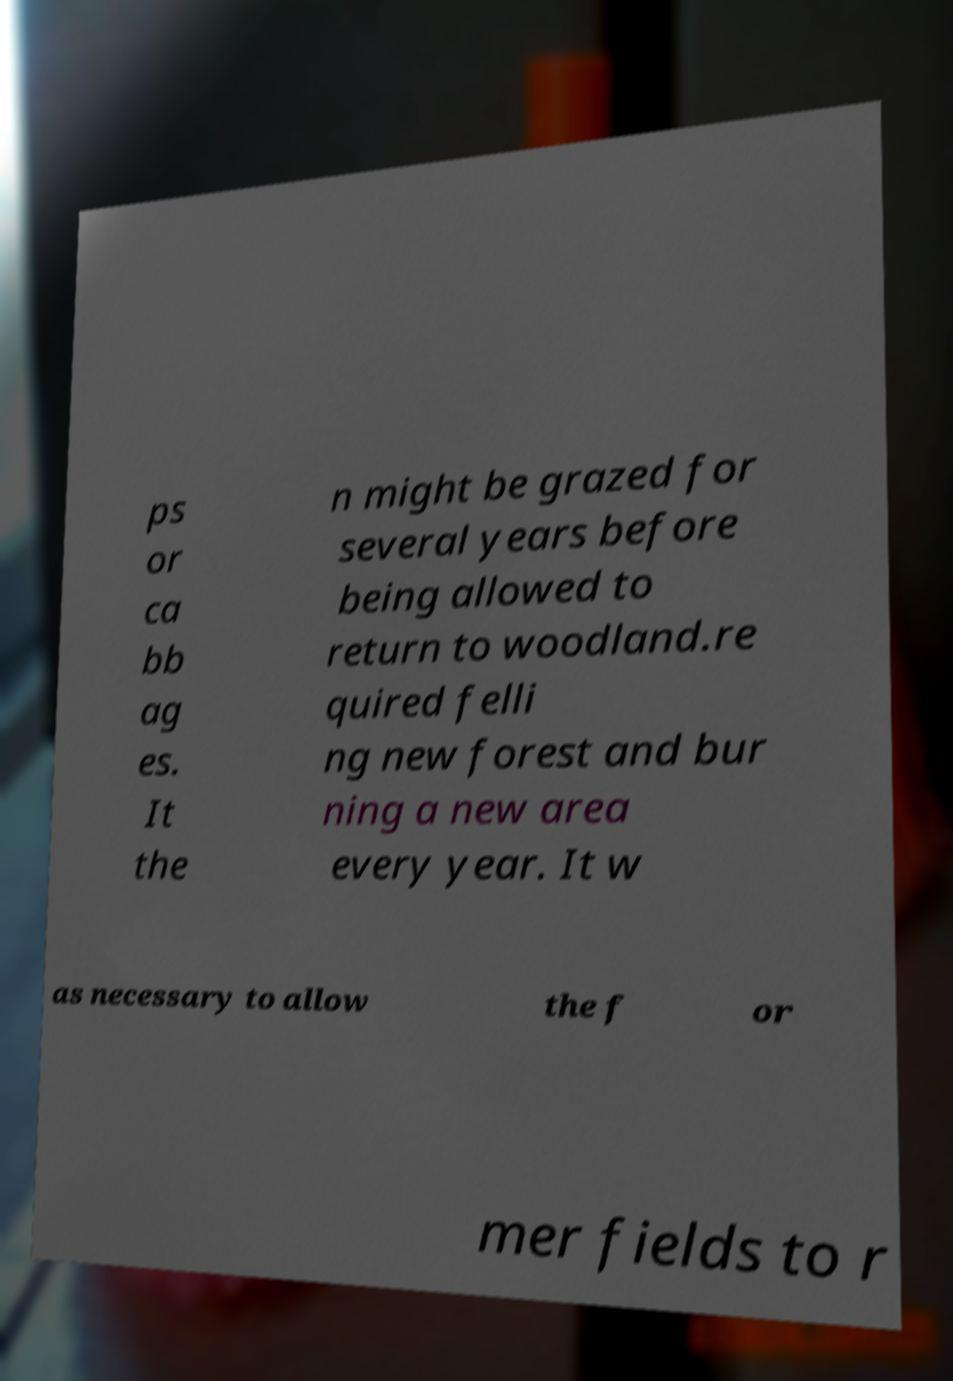Please read and relay the text visible in this image. What does it say? ps or ca bb ag es. It the n might be grazed for several years before being allowed to return to woodland.re quired felli ng new forest and bur ning a new area every year. It w as necessary to allow the f or mer fields to r 